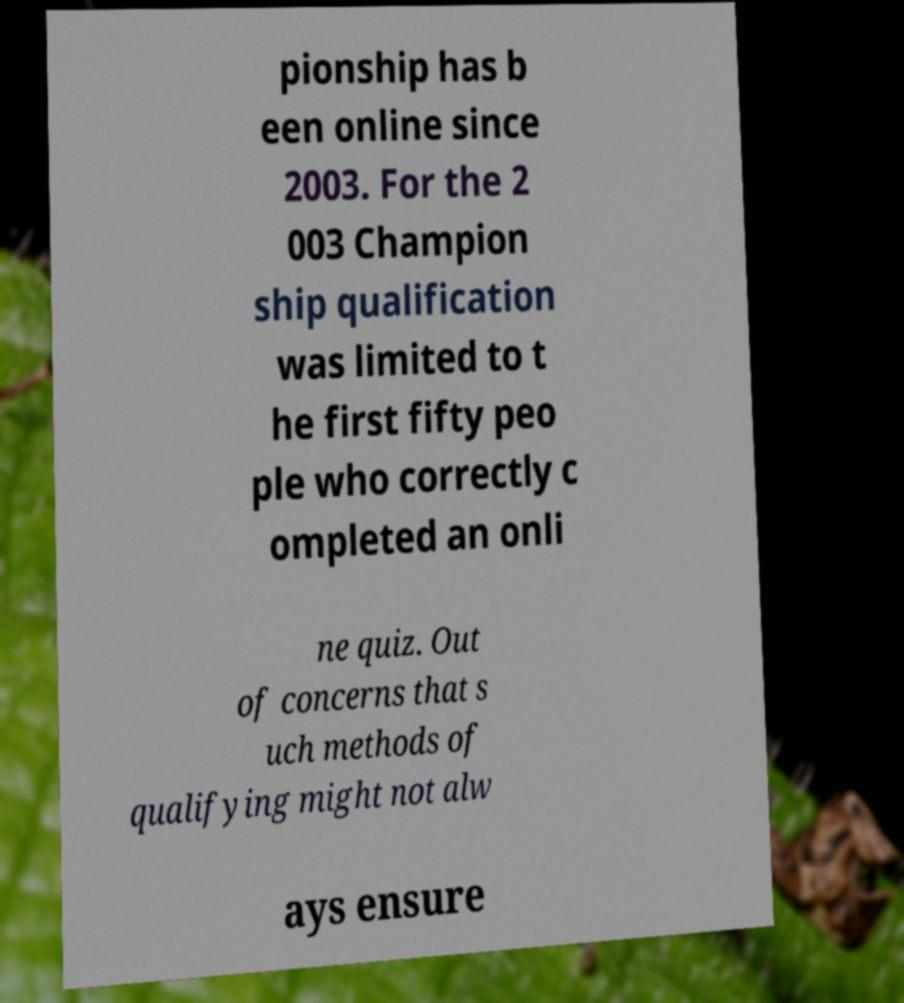Can you accurately transcribe the text from the provided image for me? pionship has b een online since 2003. For the 2 003 Champion ship qualification was limited to t he first fifty peo ple who correctly c ompleted an onli ne quiz. Out of concerns that s uch methods of qualifying might not alw ays ensure 